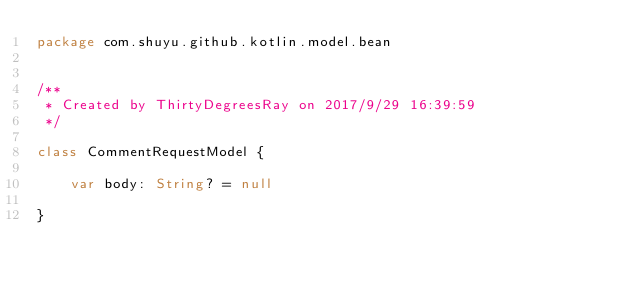<code> <loc_0><loc_0><loc_500><loc_500><_Kotlin_>package com.shuyu.github.kotlin.model.bean


/**
 * Created by ThirtyDegreesRay on 2017/9/29 16:39:59
 */

class CommentRequestModel {

    var body: String? = null

}
</code> 